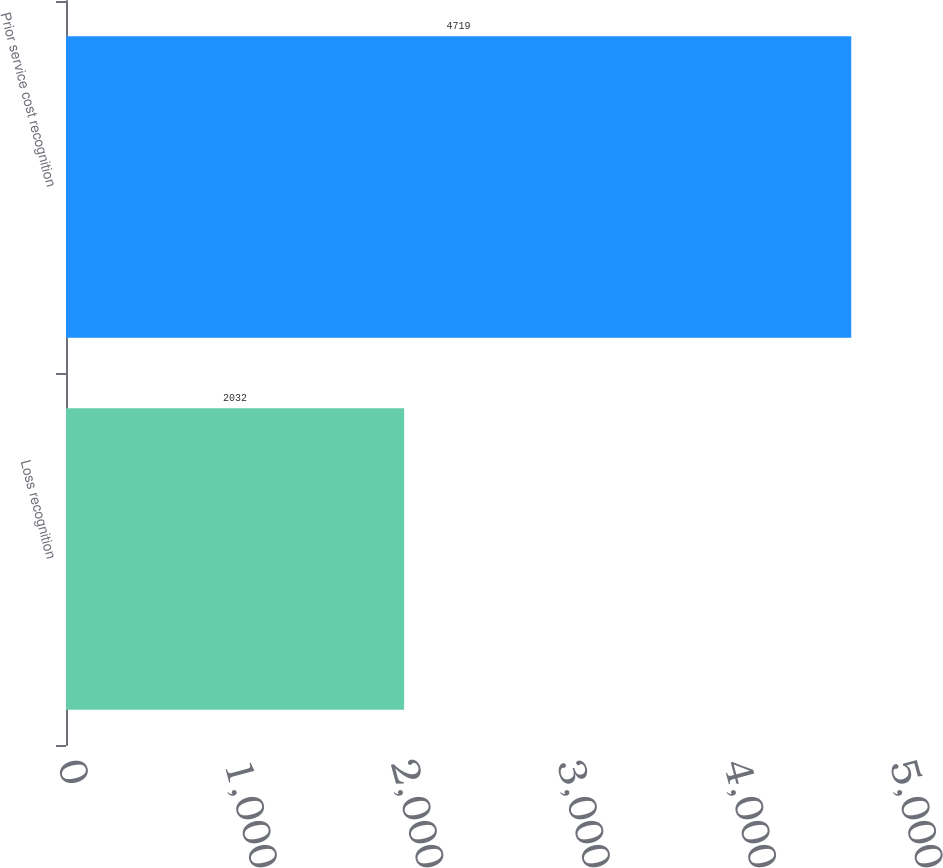Convert chart to OTSL. <chart><loc_0><loc_0><loc_500><loc_500><bar_chart><fcel>Loss recognition<fcel>Prior service cost recognition<nl><fcel>2032<fcel>4719<nl></chart> 